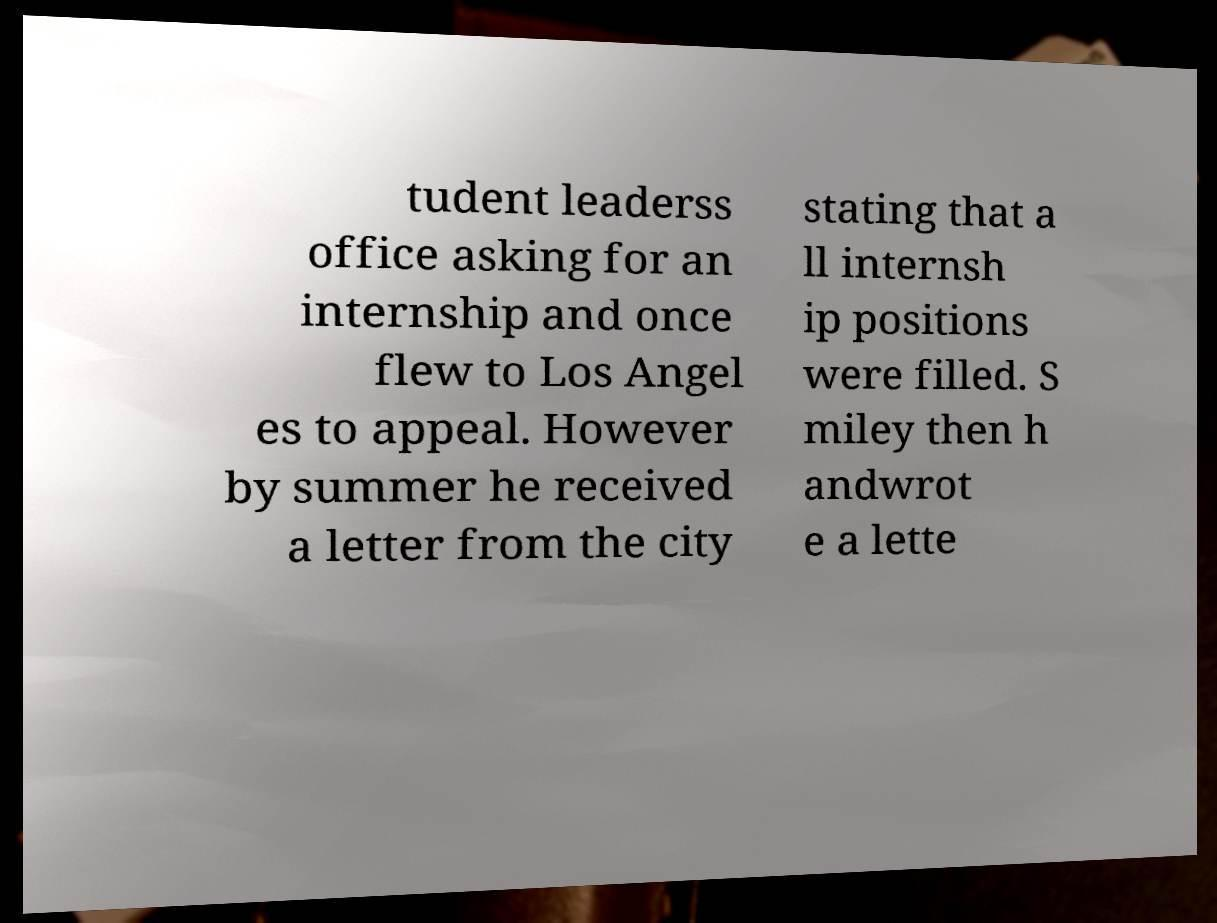What messages or text are displayed in this image? I need them in a readable, typed format. tudent leaderss office asking for an internship and once flew to Los Angel es to appeal. However by summer he received a letter from the city stating that a ll internsh ip positions were filled. S miley then h andwrot e a lette 